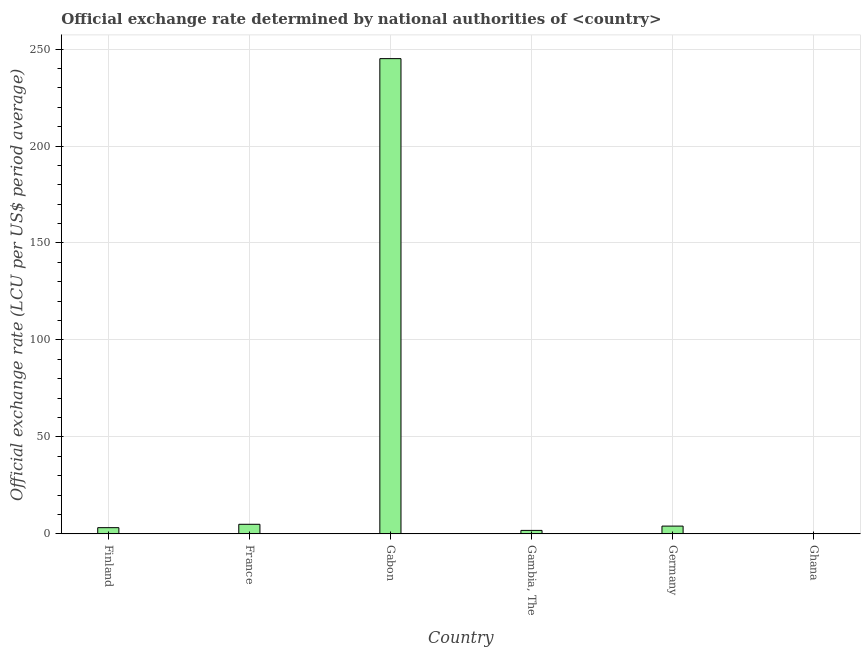What is the title of the graph?
Offer a terse response. Official exchange rate determined by national authorities of <country>. What is the label or title of the X-axis?
Keep it short and to the point. Country. What is the label or title of the Y-axis?
Offer a terse response. Official exchange rate (LCU per US$ period average). What is the official exchange rate in Gabon?
Ensure brevity in your answer.  245.06. Across all countries, what is the maximum official exchange rate?
Offer a terse response. 245.06. Across all countries, what is the minimum official exchange rate?
Provide a short and direct response. 7.13915966742473e-5. In which country was the official exchange rate maximum?
Make the answer very short. Gabon. What is the sum of the official exchange rate?
Offer a very short reply. 258.98. What is the difference between the official exchange rate in France and Germany?
Ensure brevity in your answer.  0.94. What is the average official exchange rate per country?
Give a very brief answer. 43.16. What is the median official exchange rate?
Your answer should be compact. 3.6. In how many countries, is the official exchange rate greater than 230 ?
Provide a succinct answer. 1. What is the ratio of the official exchange rate in Gambia, The to that in Ghana?
Offer a very short reply. 2.50e+04. Is the official exchange rate in France less than that in Ghana?
Ensure brevity in your answer.  No. Is the difference between the official exchange rate in Finland and France greater than the difference between any two countries?
Your answer should be very brief. No. What is the difference between the highest and the second highest official exchange rate?
Offer a very short reply. 240.12. Is the sum of the official exchange rate in Finland and Ghana greater than the maximum official exchange rate across all countries?
Make the answer very short. No. What is the difference between the highest and the lowest official exchange rate?
Keep it short and to the point. 245.06. In how many countries, is the official exchange rate greater than the average official exchange rate taken over all countries?
Your answer should be compact. 1. How many bars are there?
Provide a short and direct response. 6. What is the difference between two consecutive major ticks on the Y-axis?
Provide a short and direct response. 50. What is the Official exchange rate (LCU per US$ period average) of Finland?
Give a very brief answer. 3.2. What is the Official exchange rate (LCU per US$ period average) of France?
Offer a terse response. 4.94. What is the Official exchange rate (LCU per US$ period average) in Gabon?
Make the answer very short. 245.06. What is the Official exchange rate (LCU per US$ period average) in Gambia, The?
Ensure brevity in your answer.  1.79. What is the Official exchange rate (LCU per US$ period average) of Germany?
Offer a terse response. 4. What is the Official exchange rate (LCU per US$ period average) of Ghana?
Your response must be concise. 7.13915966742473e-5. What is the difference between the Official exchange rate (LCU per US$ period average) in Finland and France?
Your answer should be compact. -1.74. What is the difference between the Official exchange rate (LCU per US$ period average) in Finland and Gabon?
Offer a terse response. -241.86. What is the difference between the Official exchange rate (LCU per US$ period average) in Finland and Gambia, The?
Your answer should be compact. 1.41. What is the difference between the Official exchange rate (LCU per US$ period average) in Finland and Ghana?
Ensure brevity in your answer.  3.2. What is the difference between the Official exchange rate (LCU per US$ period average) in France and Gabon?
Offer a terse response. -240.12. What is the difference between the Official exchange rate (LCU per US$ period average) in France and Gambia, The?
Your answer should be very brief. 3.15. What is the difference between the Official exchange rate (LCU per US$ period average) in France and Germany?
Offer a very short reply. 0.94. What is the difference between the Official exchange rate (LCU per US$ period average) in France and Ghana?
Make the answer very short. 4.94. What is the difference between the Official exchange rate (LCU per US$ period average) in Gabon and Gambia, The?
Provide a succinct answer. 243.28. What is the difference between the Official exchange rate (LCU per US$ period average) in Gabon and Germany?
Offer a terse response. 241.06. What is the difference between the Official exchange rate (LCU per US$ period average) in Gabon and Ghana?
Your response must be concise. 245.06. What is the difference between the Official exchange rate (LCU per US$ period average) in Gambia, The and Germany?
Your response must be concise. -2.21. What is the difference between the Official exchange rate (LCU per US$ period average) in Gambia, The and Ghana?
Your response must be concise. 1.79. What is the difference between the Official exchange rate (LCU per US$ period average) in Germany and Ghana?
Ensure brevity in your answer.  4. What is the ratio of the Official exchange rate (LCU per US$ period average) in Finland to that in France?
Ensure brevity in your answer.  0.65. What is the ratio of the Official exchange rate (LCU per US$ period average) in Finland to that in Gabon?
Make the answer very short. 0.01. What is the ratio of the Official exchange rate (LCU per US$ period average) in Finland to that in Gambia, The?
Provide a short and direct response. 1.79. What is the ratio of the Official exchange rate (LCU per US$ period average) in Finland to that in Germany?
Ensure brevity in your answer.  0.8. What is the ratio of the Official exchange rate (LCU per US$ period average) in Finland to that in Ghana?
Offer a terse response. 4.48e+04. What is the ratio of the Official exchange rate (LCU per US$ period average) in France to that in Gambia, The?
Give a very brief answer. 2.77. What is the ratio of the Official exchange rate (LCU per US$ period average) in France to that in Germany?
Make the answer very short. 1.23. What is the ratio of the Official exchange rate (LCU per US$ period average) in France to that in Ghana?
Give a very brief answer. 6.92e+04. What is the ratio of the Official exchange rate (LCU per US$ period average) in Gabon to that in Gambia, The?
Your response must be concise. 137.23. What is the ratio of the Official exchange rate (LCU per US$ period average) in Gabon to that in Germany?
Your response must be concise. 61.27. What is the ratio of the Official exchange rate (LCU per US$ period average) in Gabon to that in Ghana?
Your answer should be very brief. 3.43e+06. What is the ratio of the Official exchange rate (LCU per US$ period average) in Gambia, The to that in Germany?
Your answer should be compact. 0.45. What is the ratio of the Official exchange rate (LCU per US$ period average) in Gambia, The to that in Ghana?
Your response must be concise. 2.50e+04. What is the ratio of the Official exchange rate (LCU per US$ period average) in Germany to that in Ghana?
Your answer should be compact. 5.60e+04. 